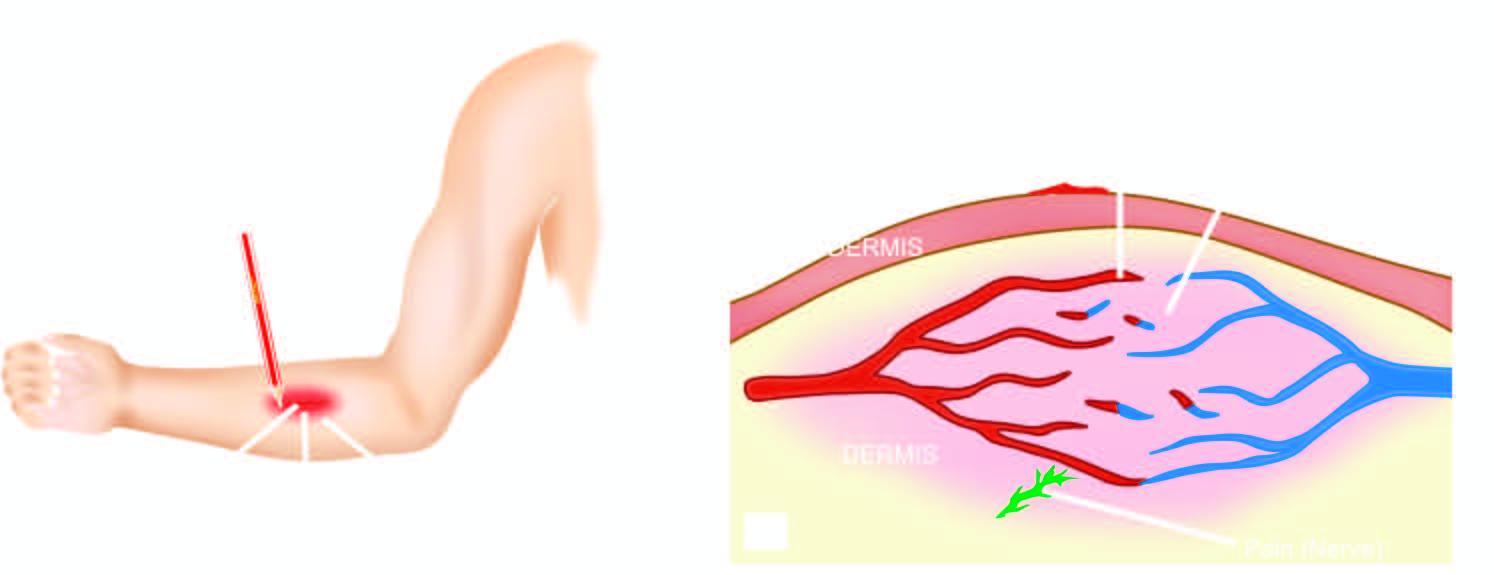how is 'triple response ' elicited?
Answer the question using a single word or phrase. By firm stroking of skin of forearm with a pencil 